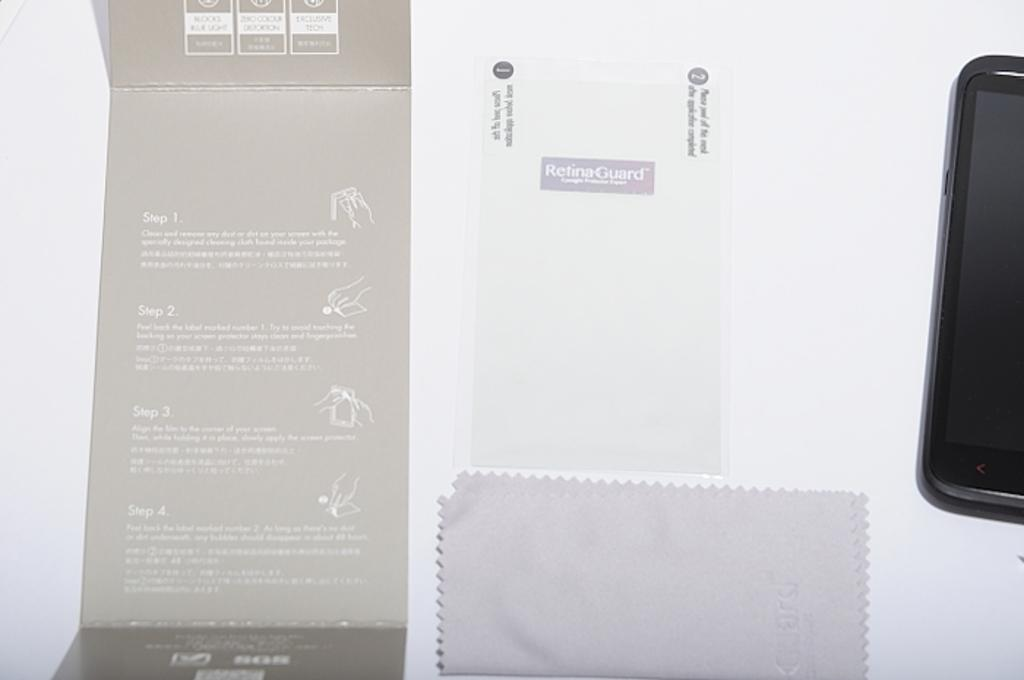Provide a one-sentence caption for the provided image. A Samsung smart phone is powered off and laying sideways. 